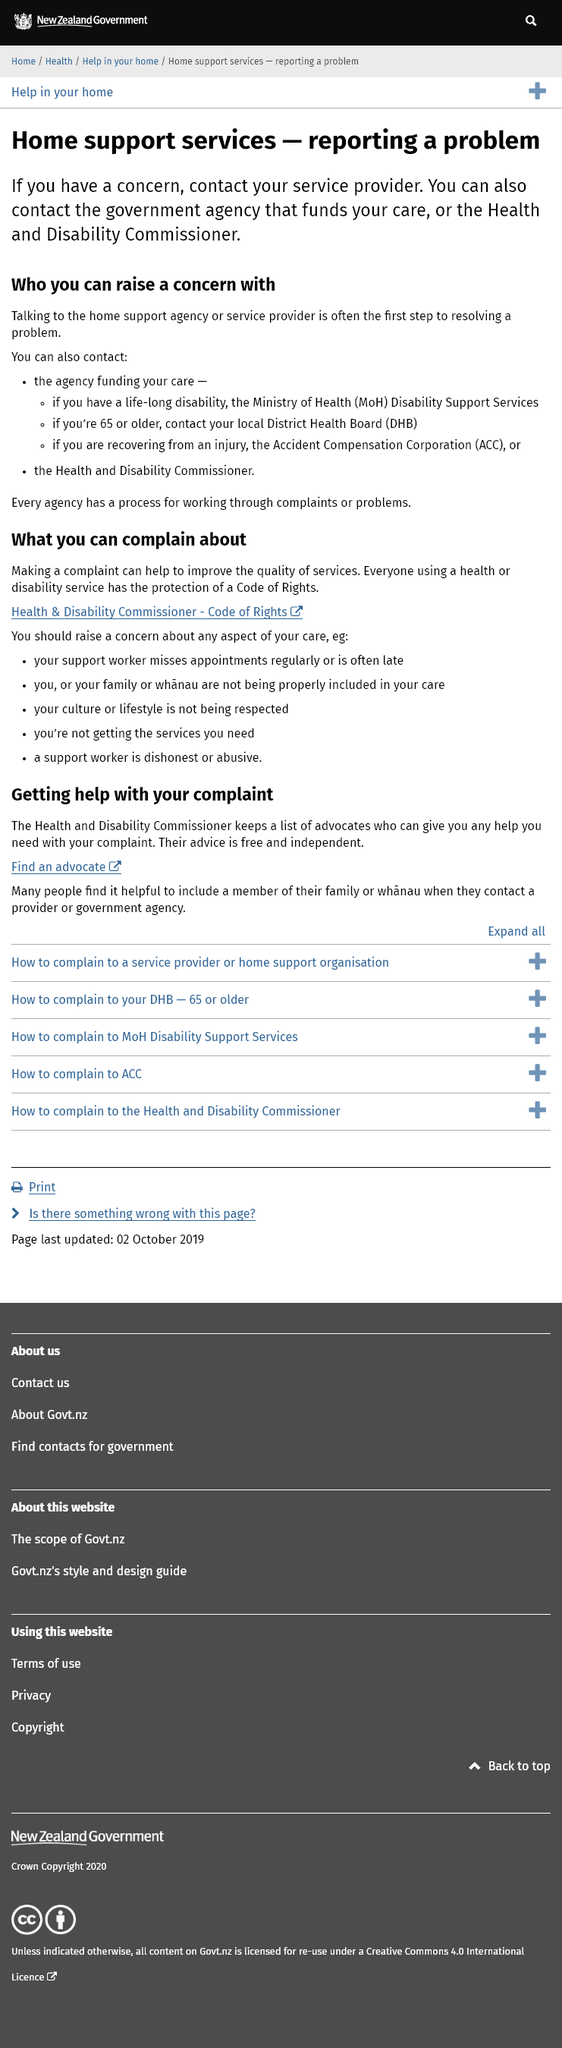Indicate a few pertinent items in this graphic. It is possible to bring a concern regarding home support services to the attention of the Health and Disability Commissioner. Every agency has a process for working through complaints or problems. The first step in resolving a problem regarding home support services is often talking to the home support agency or service provider. 